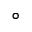Convert formula to latex. <formula><loc_0><loc_0><loc_500><loc_500>^ { \circ }</formula> 